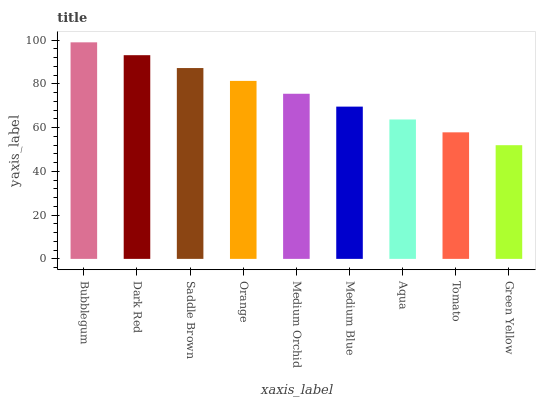Is Dark Red the minimum?
Answer yes or no. No. Is Dark Red the maximum?
Answer yes or no. No. Is Bubblegum greater than Dark Red?
Answer yes or no. Yes. Is Dark Red less than Bubblegum?
Answer yes or no. Yes. Is Dark Red greater than Bubblegum?
Answer yes or no. No. Is Bubblegum less than Dark Red?
Answer yes or no. No. Is Medium Orchid the high median?
Answer yes or no. Yes. Is Medium Orchid the low median?
Answer yes or no. Yes. Is Medium Blue the high median?
Answer yes or no. No. Is Medium Blue the low median?
Answer yes or no. No. 